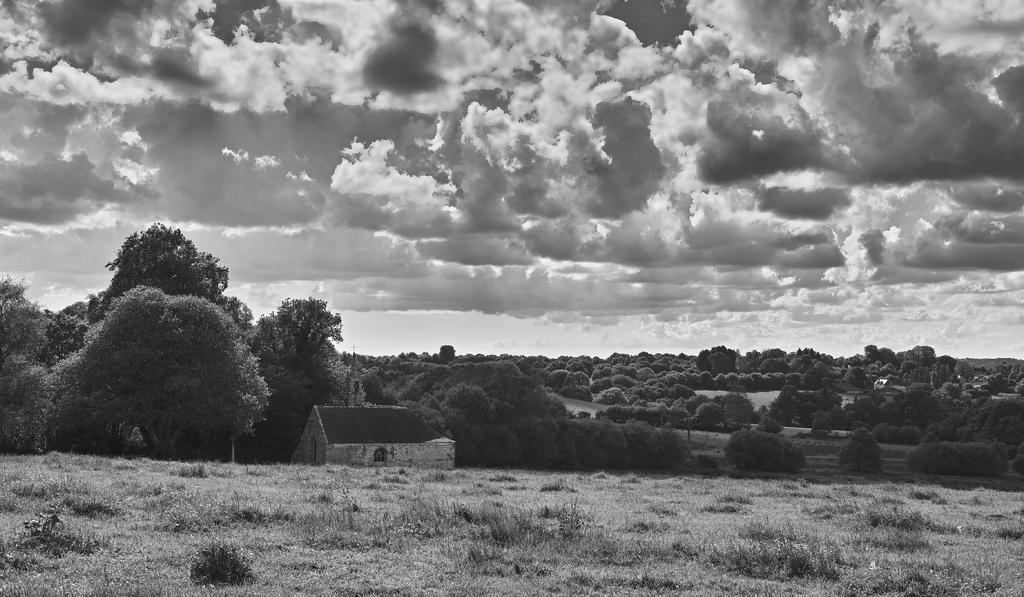What is the color scheme of the image? The image is black and white. What can be seen on the ground at the bottom of the image? There are plants and grass on the ground at the bottom of the image. What type of structure is present in the image? There is a house in the image. Can you describe a feature of the house? There is a window in the house. What is visible in the background of the image? There are trees and clouds in the sky in the background of the image. Where is the store located in the image? There is no store present in the image. Can you see a badge on any of the plants in the image? There are no badges visible on the plants in the image. 